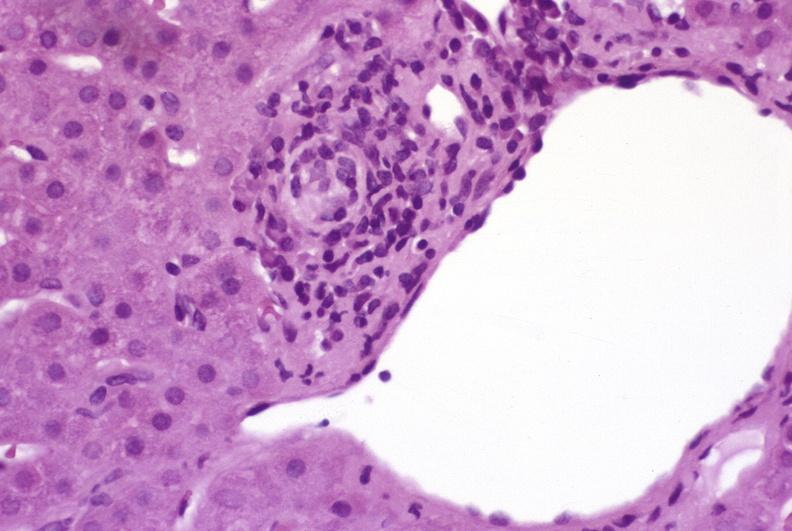what is present?
Answer the question using a single word or phrase. Hepatobiliary 